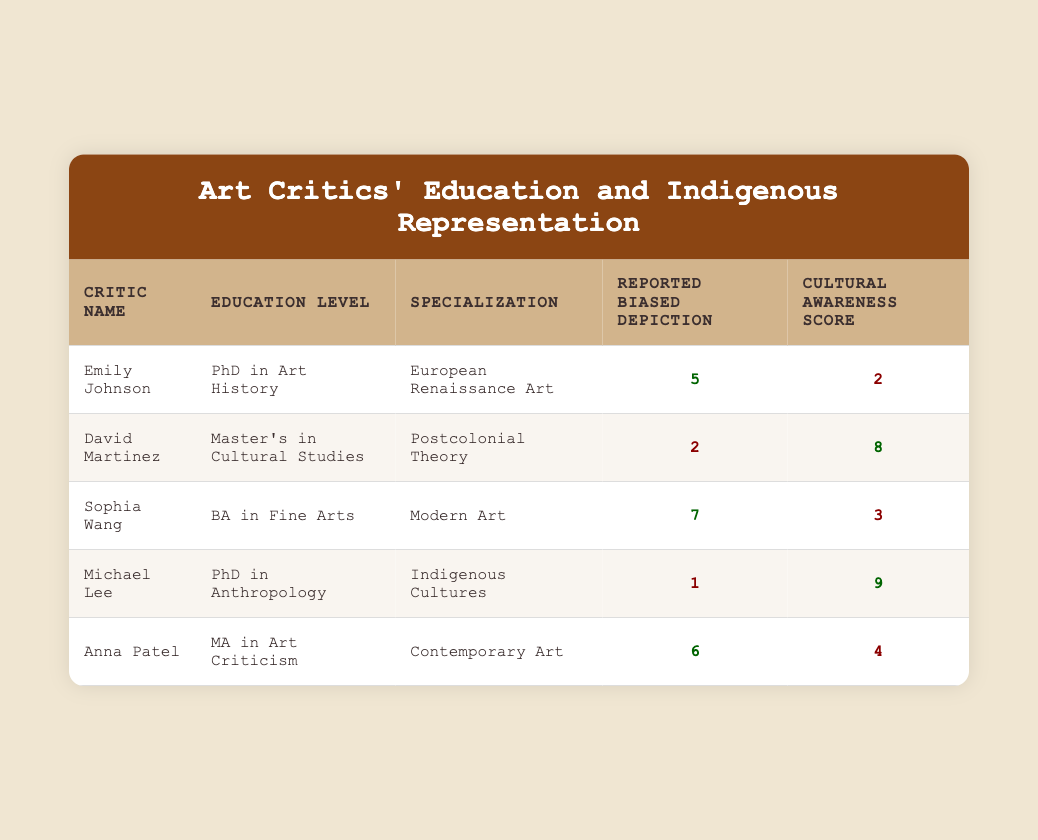What is the education level of Michael Lee? Michael Lee's education level is listed in the table under the "Education Level" column. It states "PhD in Anthropology."
Answer: PhD in Anthropology Which critic reported the highest biased depiction? Looking at the "Reported Biased Depiction" column, the highest value is 7, which is reported by Sophia Wang.
Answer: Sophia Wang Is there any critic with a cultural awareness score of 9? Checking the "Cultural Awareness Score" column, Michael Lee scores 9. Therefore, yes, there is a critic with that score.
Answer: Yes What is the average cultural awareness score of the critics? To calculate the average, we sum the scores: 2 + 8 + 3 + 9 + 4 = 26. Then we divide by the number of critics (5). 26/5 = 5.2
Answer: 5.2 Which critic has the lowest reported biased depiction, and what is that value? By examining the "Reported Biased Depiction" column, we find that Michael Lee has the lowest value, which is 1.
Answer: Michael Lee, 1 Is the education level of David Martinez higher than that of Anna Patel? David Martinez has a Master's degree while Anna Patel has an MA, which is equivalent, but neither is higher than a PhD level. Therefore, the answer is no.
Answer: No How many critics have a cultural awareness score of 5 or higher? Looking through the "Cultural Awareness Score" column, the critics with scores of 5 or higher are David Martinez (8), Michael Lee (9), and Anna Patel (4). This gives us a total of 3 critics.
Answer: 3 What is the difference in reported biased depictions between Sophia Wang and David Martinez? Sophia Wang's score is 7 and David Martinez's score is 2. The difference is 7 - 2 = 5.
Answer: 5 Which two critics have a similar educational background in terms of Master’s and Bachelor's degrees? David Martinez has a Master's degree and so does Anna Patel. Sophia Wang has a Bachelor's degree. Therefore, the two critics with similarities are David Martinez and Anna Patel, but they hold different degrees.
Answer: David Martinez and Anna Patel 